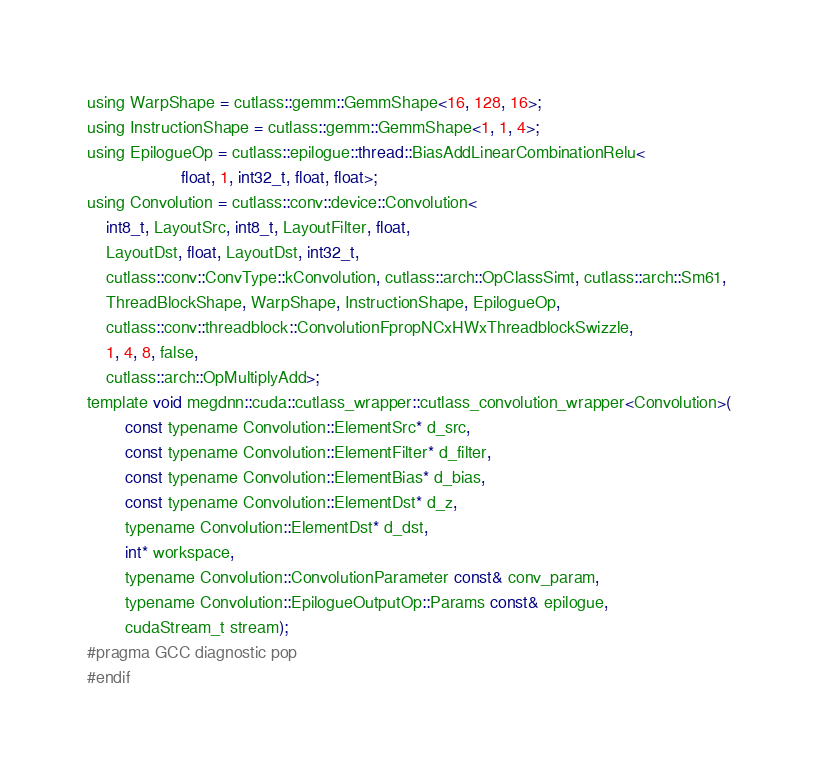Convert code to text. <code><loc_0><loc_0><loc_500><loc_500><_Cuda_>using WarpShape = cutlass::gemm::GemmShape<16, 128, 16>;
using InstructionShape = cutlass::gemm::GemmShape<1, 1, 4>;
using EpilogueOp = cutlass::epilogue::thread::BiasAddLinearCombinationRelu<
                    float, 1, int32_t, float, float>;
using Convolution = cutlass::conv::device::Convolution<
    int8_t, LayoutSrc, int8_t, LayoutFilter, float, 
    LayoutDst, float, LayoutDst, int32_t, 
    cutlass::conv::ConvType::kConvolution, cutlass::arch::OpClassSimt, cutlass::arch::Sm61, 
    ThreadBlockShape, WarpShape, InstructionShape, EpilogueOp, 
    cutlass::conv::threadblock::ConvolutionFpropNCxHWxThreadblockSwizzle, 
    1, 4, 8, false, 
    cutlass::arch::OpMultiplyAdd>;
template void megdnn::cuda::cutlass_wrapper::cutlass_convolution_wrapper<Convolution>(
        const typename Convolution::ElementSrc* d_src, 
        const typename Convolution::ElementFilter* d_filter, 
        const typename Convolution::ElementBias* d_bias, 
        const typename Convolution::ElementDst* d_z, 
        typename Convolution::ElementDst* d_dst, 
        int* workspace, 
        typename Convolution::ConvolutionParameter const& conv_param, 
        typename Convolution::EpilogueOutputOp::Params const& epilogue, 
        cudaStream_t stream);
#pragma GCC diagnostic pop
#endif
</code> 